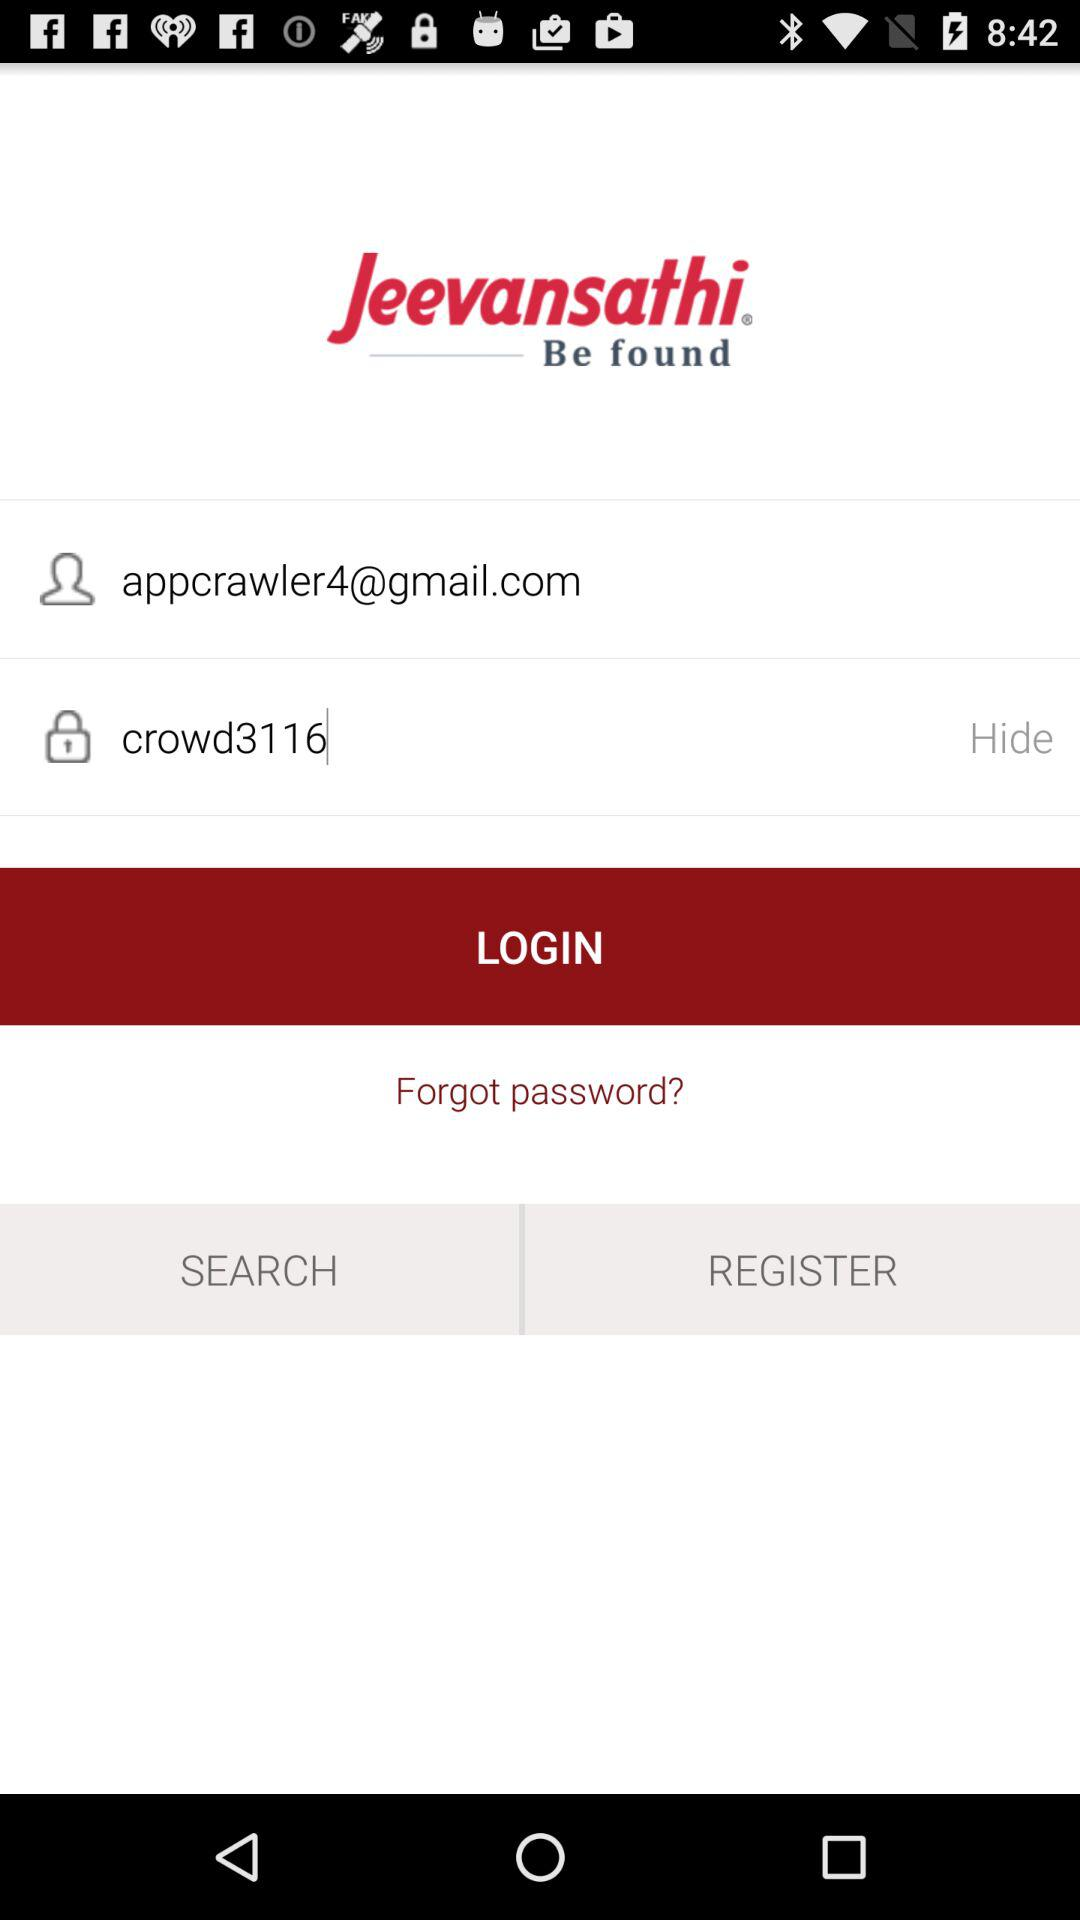What is the name of the application? The name of the application is "Jeevansathi". 